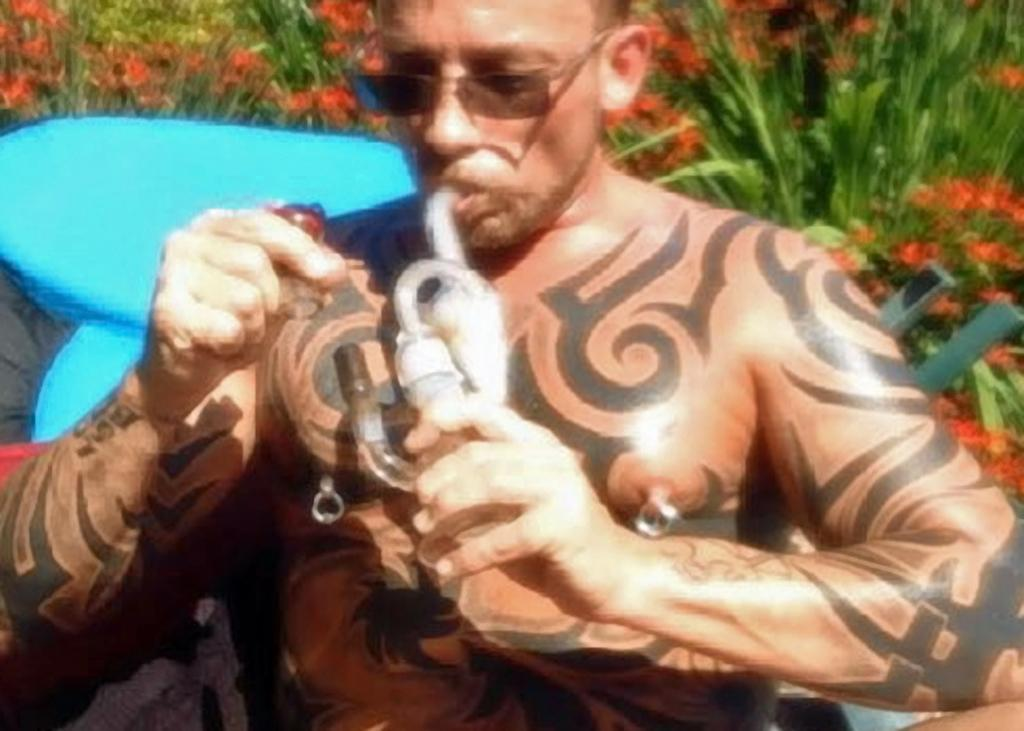What is the person in the image holding? There is a person holding an object in the image. What can be seen in the background of the image? There are orange flowers, an object in blue color, and green plants in the background of the image. How many ducks are visible in the image? There are no ducks present in the image. What type of ring is the person wearing in the image? There is no ring visible on the person in the image. 